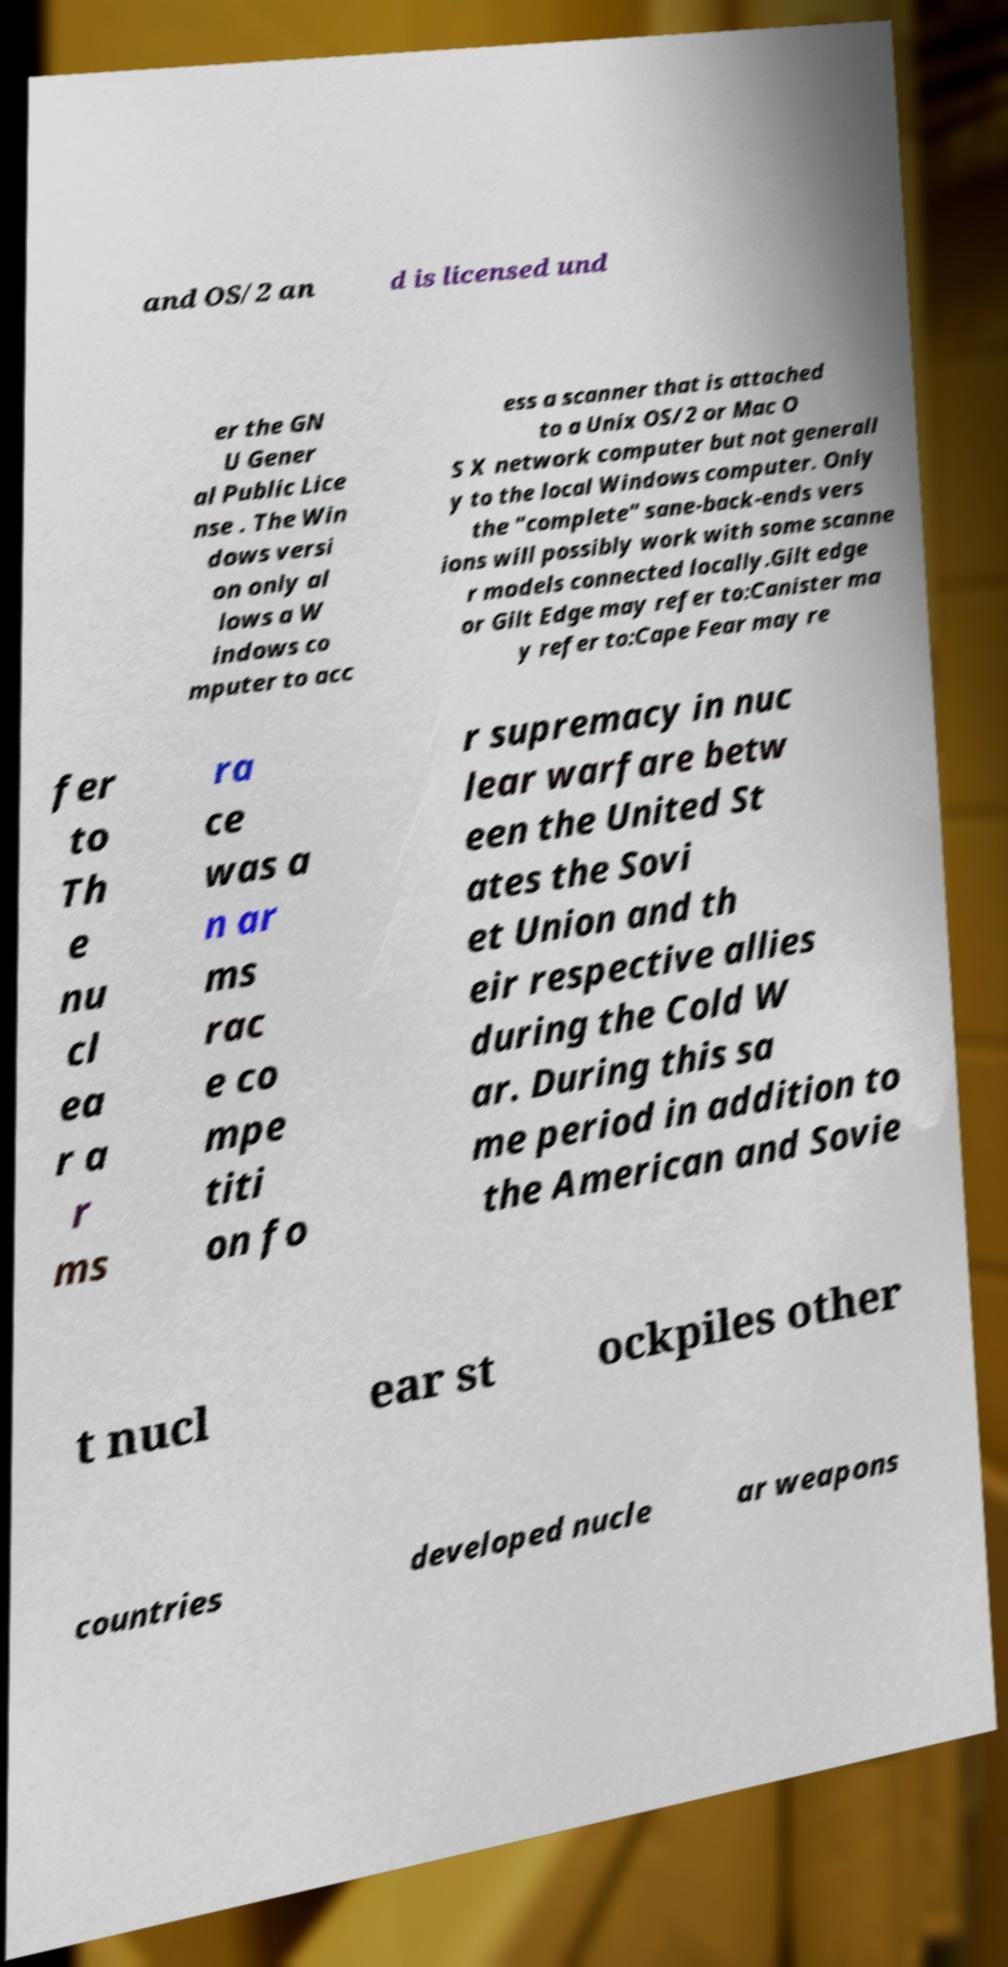For documentation purposes, I need the text within this image transcribed. Could you provide that? and OS/2 an d is licensed und er the GN U Gener al Public Lice nse . The Win dows versi on only al lows a W indows co mputer to acc ess a scanner that is attached to a Unix OS/2 or Mac O S X network computer but not generall y to the local Windows computer. Only the "complete" sane-back-ends vers ions will possibly work with some scanne r models connected locally.Gilt edge or Gilt Edge may refer to:Canister ma y refer to:Cape Fear may re fer to Th e nu cl ea r a r ms ra ce was a n ar ms rac e co mpe titi on fo r supremacy in nuc lear warfare betw een the United St ates the Sovi et Union and th eir respective allies during the Cold W ar. During this sa me period in addition to the American and Sovie t nucl ear st ockpiles other countries developed nucle ar weapons 